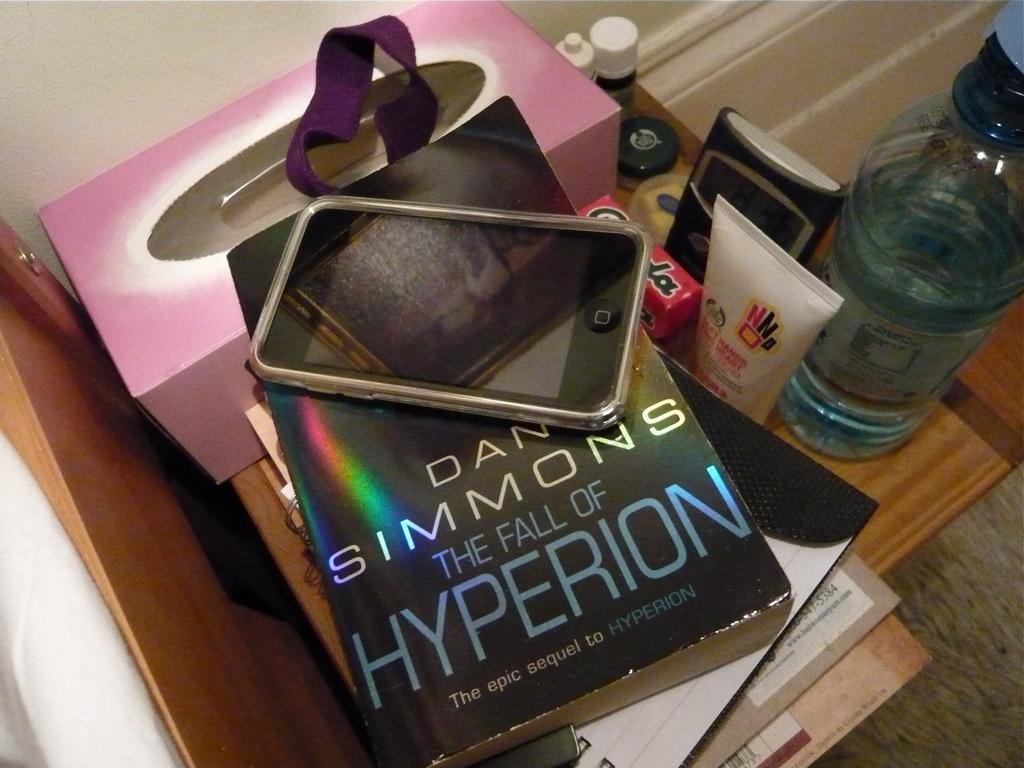What is the title of this book?
Provide a succinct answer. The fall of hyperion. Who is the author of this book?
Keep it short and to the point. Dan simmons. 